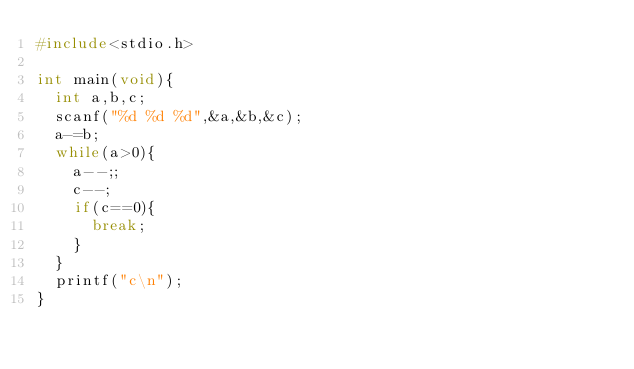<code> <loc_0><loc_0><loc_500><loc_500><_C_>#include<stdio.h>

int main(void){
  int a,b,c;
  scanf("%d %d %d",&a,&b,&c);
  a-=b;
  while(a>0){
    a--;;
    c--;
    if(c==0){
      break;
    }
  }
  printf("c\n");
}</code> 